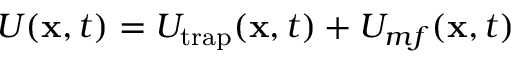Convert formula to latex. <formula><loc_0><loc_0><loc_500><loc_500>U ( x , t ) = U _ { t r a p } ( x , t ) + U _ { m f } ( x , t )</formula> 